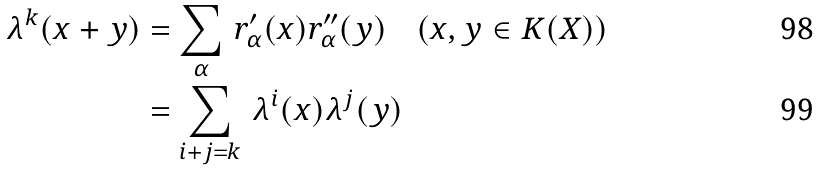<formula> <loc_0><loc_0><loc_500><loc_500>\lambda ^ { k } ( x + y ) & = \sum _ { \alpha } \, r _ { \alpha } ^ { \prime } ( x ) r _ { \alpha } ^ { \prime \prime } ( y ) \quad ( x , y \in K ( X ) ) \\ & = \sum _ { i + j = k } \, \lambda ^ { i } ( x ) \lambda ^ { j } ( y )</formula> 